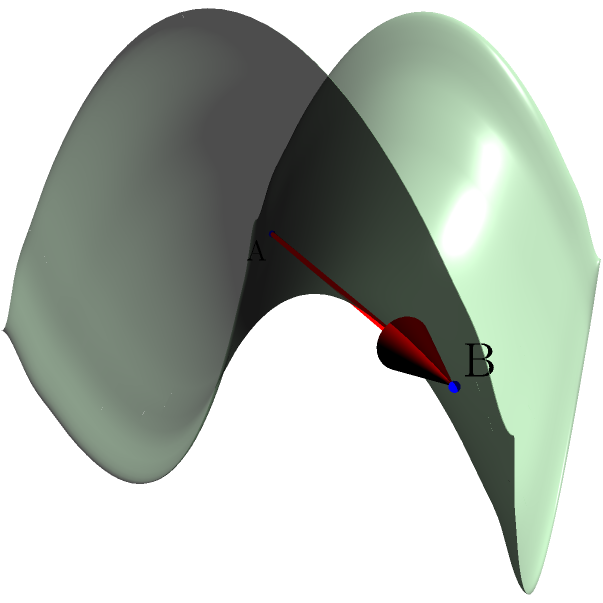In the context of non-Euclidean geometry, consider the saddle-shaped surface shown above. Points A and B are marked on the surface. Which of the following statements best describes the shortest path (geodesic) between these two points?

a) The shortest path is a straight line between A and B.
b) The shortest path follows the curve of the saddle's "valley."
c) The shortest path is a curved line that deviates from both the straight line and the saddle's "valley."
d) There is no unique shortest path between A and B on this surface.

How might understanding this concept help in developing spatial reasoning skills for students in underprivileged schools? To understand the shortest path (geodesic) between two points on a saddle-shaped surface, we need to consider the following steps:

1) In Euclidean geometry (flat space), the shortest path between two points is always a straight line. However, on curved surfaces, this is not necessarily true.

2) A saddle-shaped surface is an example of a hyperbolic surface, which has negative curvature.

3) On a hyperbolic surface, geodesics (shortest paths) tend to "bow outward" from what would be a straight line in flat space.

4) The path shown in red on the diagram is not actually the geodesic, but rather a straight line connecting A and B if the surface were flattened out.

5) The true geodesic would curve away from this line, avoiding the areas of greatest curvature (the center of the saddle).

6) It would not follow the "valley" of the saddle either, as this would be a longer path.

7) Instead, it would take a curved path that balances between avoiding high curvature areas and minimizing distance.

Understanding this concept can help develop spatial reasoning skills for students in underprivileged schools by:

a) Encouraging abstract thinking about three-dimensional spaces.
b) Demonstrating that intuitive solutions (like "always take a straight line") don't always work in complex situations.
c) Introducing the idea that the nature of space itself can affect movement and distance.
d) Providing a concrete example of how mathematical concepts can describe real-world phenomena.
Answer: c) The shortest path is a curved line that deviates from both the straight line and the saddle's "valley." 